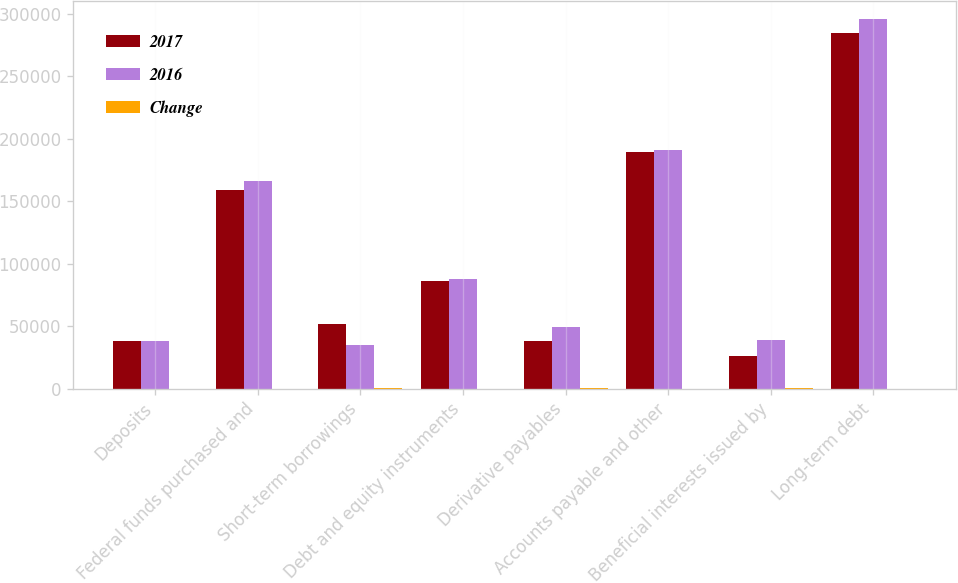Convert chart. <chart><loc_0><loc_0><loc_500><loc_500><stacked_bar_chart><ecel><fcel>Deposits<fcel>Federal funds purchased and<fcel>Short-term borrowings<fcel>Debt and equity instruments<fcel>Derivative payables<fcel>Accounts payable and other<fcel>Beneficial interests issued by<fcel>Long-term debt<nl><fcel>2017<fcel>38412<fcel>158916<fcel>51802<fcel>85886<fcel>37777<fcel>189383<fcel>26081<fcel>284080<nl><fcel>2016<fcel>38412<fcel>165666<fcel>34443<fcel>87428<fcel>49231<fcel>190543<fcel>39047<fcel>295245<nl><fcel>Change<fcel>5<fcel>4<fcel>50<fcel>2<fcel>23<fcel>1<fcel>33<fcel>4<nl></chart> 